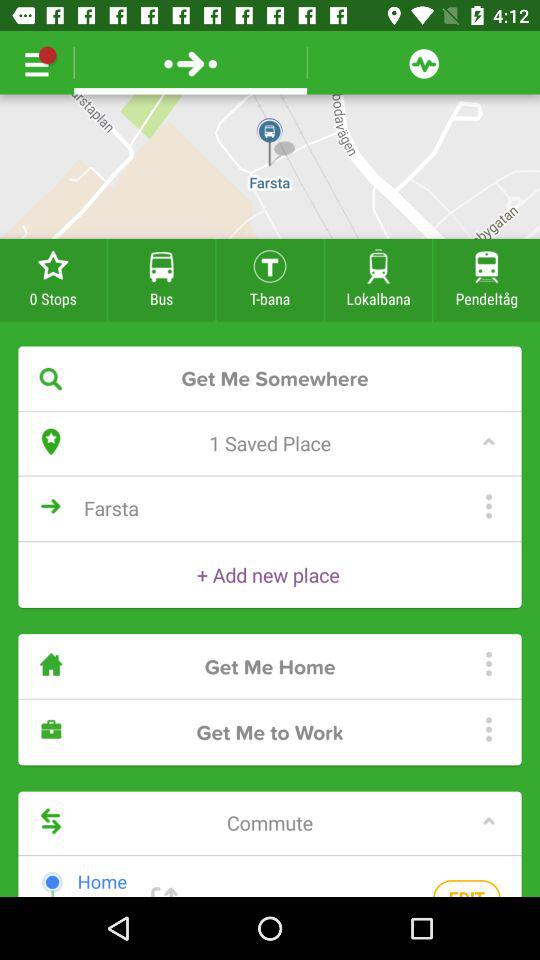How many favorite stops are there? There are 0 favorite stops. 